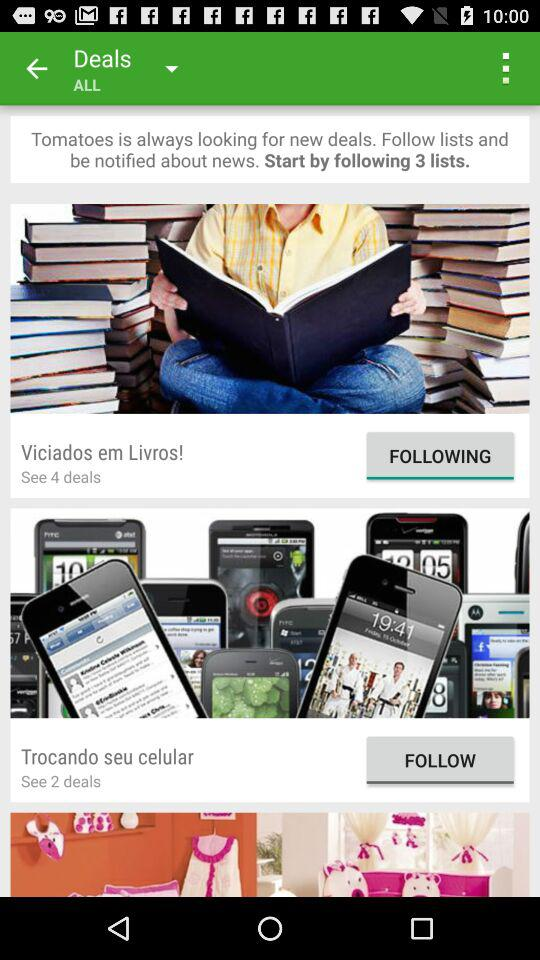How many deals are there in viciados em livros? There are 4 deals in the viciados em livros. 